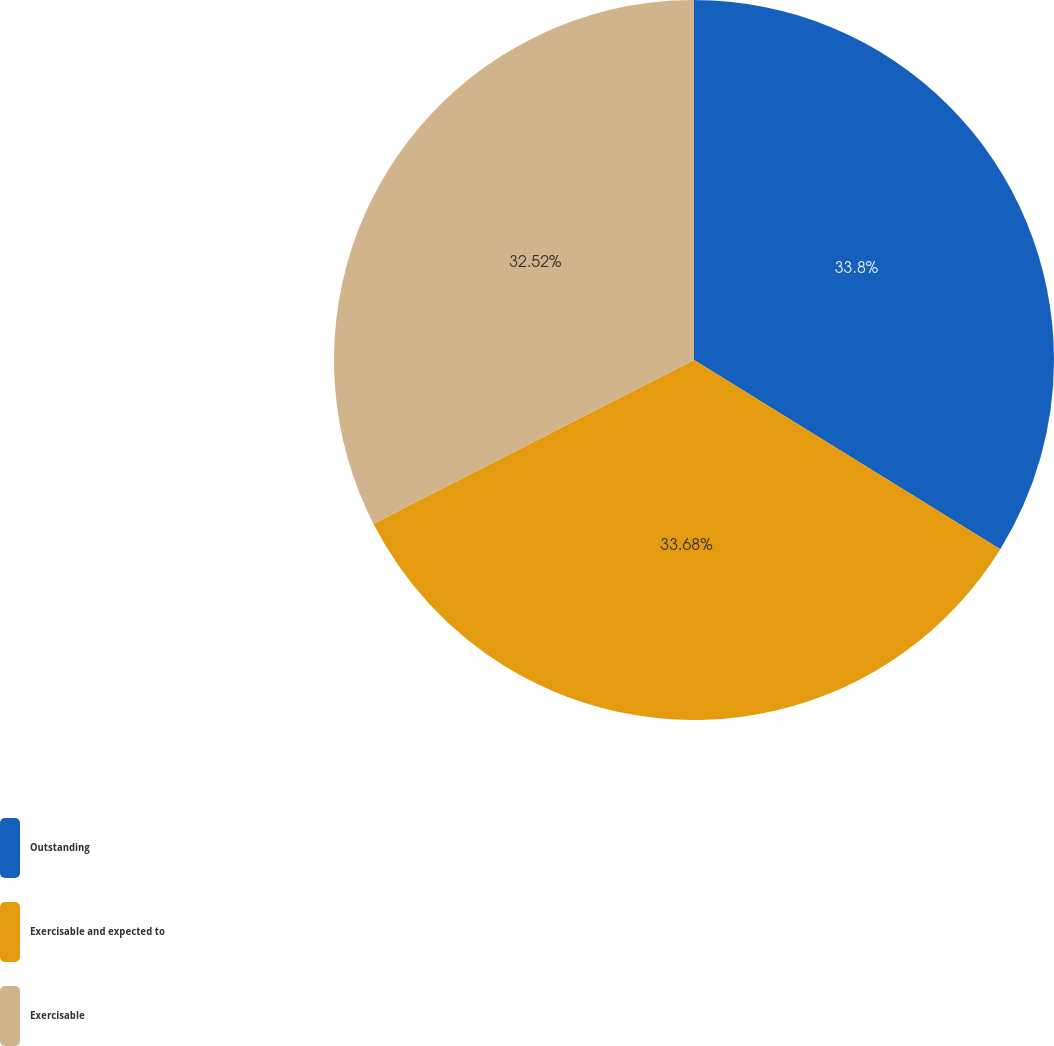Convert chart. <chart><loc_0><loc_0><loc_500><loc_500><pie_chart><fcel>Outstanding<fcel>Exercisable and expected to<fcel>Exercisable<nl><fcel>33.81%<fcel>33.68%<fcel>32.52%<nl></chart> 